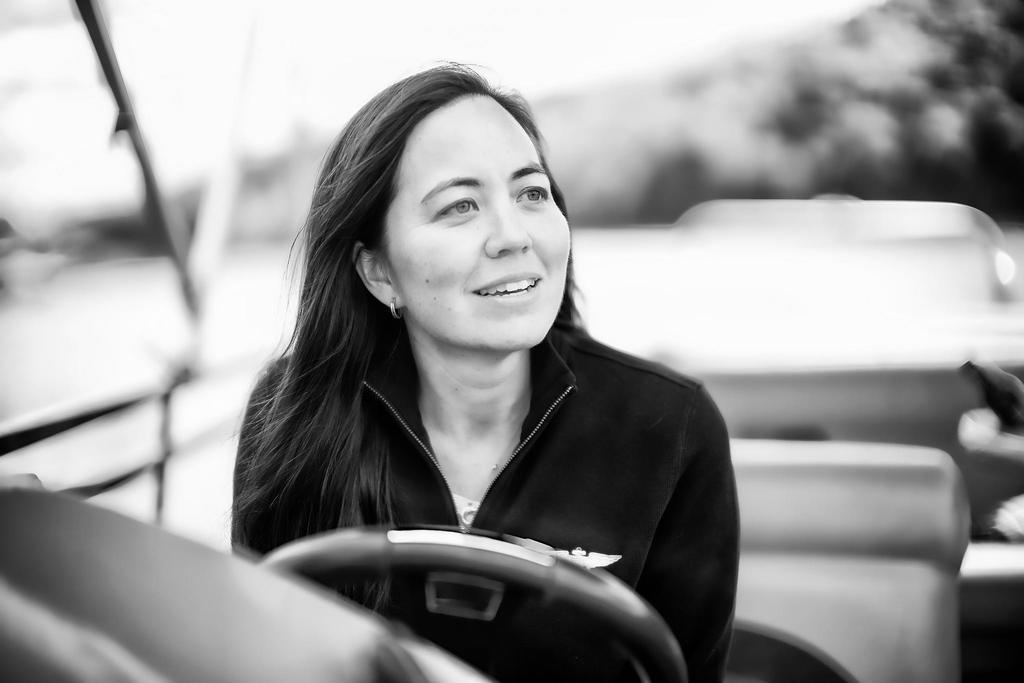What is the color scheme of the image? The image is black and white. What is the main subject of the image? There is a woman sitting in a vehicle in the center of the image. What is the woman doing in the image? The woman is sitting in a vehicle, which suggests she might be driving or riding in it. What can be seen in front of the woman? There is a steering wheel in front of the woman. What is the condition of the background in the image? The background of the image is blurred. What type of disease is the woman suffering from in the image? There is no indication of any disease in the image; it only shows a woman sitting in a vehicle. What kind of structure is visible in the background of the image? There is no specific structure visible in the background of the image; it is blurred. 